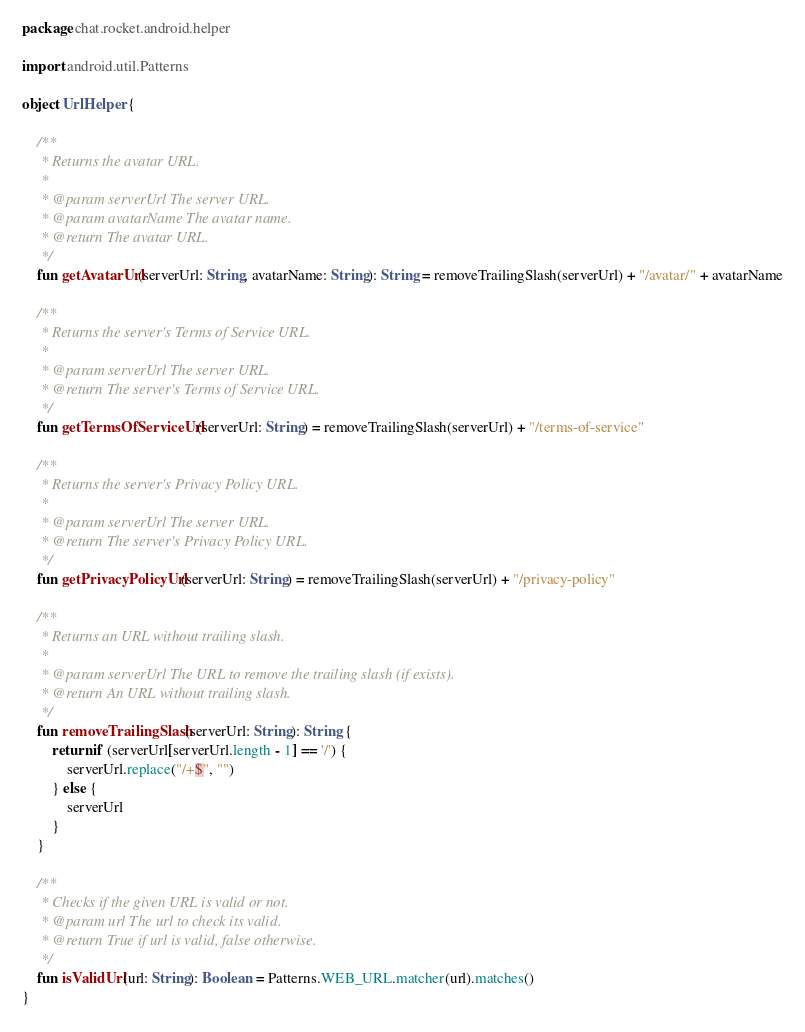Convert code to text. <code><loc_0><loc_0><loc_500><loc_500><_Kotlin_>package chat.rocket.android.helper

import android.util.Patterns

object UrlHelper {

    /**
     * Returns the avatar URL.
     *
     * @param serverUrl The server URL.
     * @param avatarName The avatar name.
     * @return The avatar URL.
     */
    fun getAvatarUrl(serverUrl: String, avatarName: String): String = removeTrailingSlash(serverUrl) + "/avatar/" + avatarName

    /**
     * Returns the server's Terms of Service URL.
     *
     * @param serverUrl The server URL.
     * @return The server's Terms of Service URL.
     */
    fun getTermsOfServiceUrl(serverUrl: String) = removeTrailingSlash(serverUrl) + "/terms-of-service"

    /**
     * Returns the server's Privacy Policy URL.
     *
     * @param serverUrl The server URL.
     * @return The server's Privacy Policy URL.
     */
    fun getPrivacyPolicyUrl(serverUrl: String) = removeTrailingSlash(serverUrl) + "/privacy-policy"

    /**
     * Returns an URL without trailing slash.
     *
     * @param serverUrl The URL to remove the trailing slash (if exists).
     * @return An URL without trailing slash.
     */
    fun removeTrailingSlash(serverUrl: String): String {
        return if (serverUrl[serverUrl.length - 1] == '/') {
            serverUrl.replace("/+$", "")
        } else {
            serverUrl
        }
    }

    /**
     * Checks if the given URL is valid or not.
     * @param url The url to check its valid.
     * @return True if url is valid, false otherwise.
     */
    fun isValidUrl(url: String): Boolean = Patterns.WEB_URL.matcher(url).matches()
}</code> 